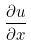Convert formula to latex. <formula><loc_0><loc_0><loc_500><loc_500>\frac { \partial u } { \partial x }</formula> 